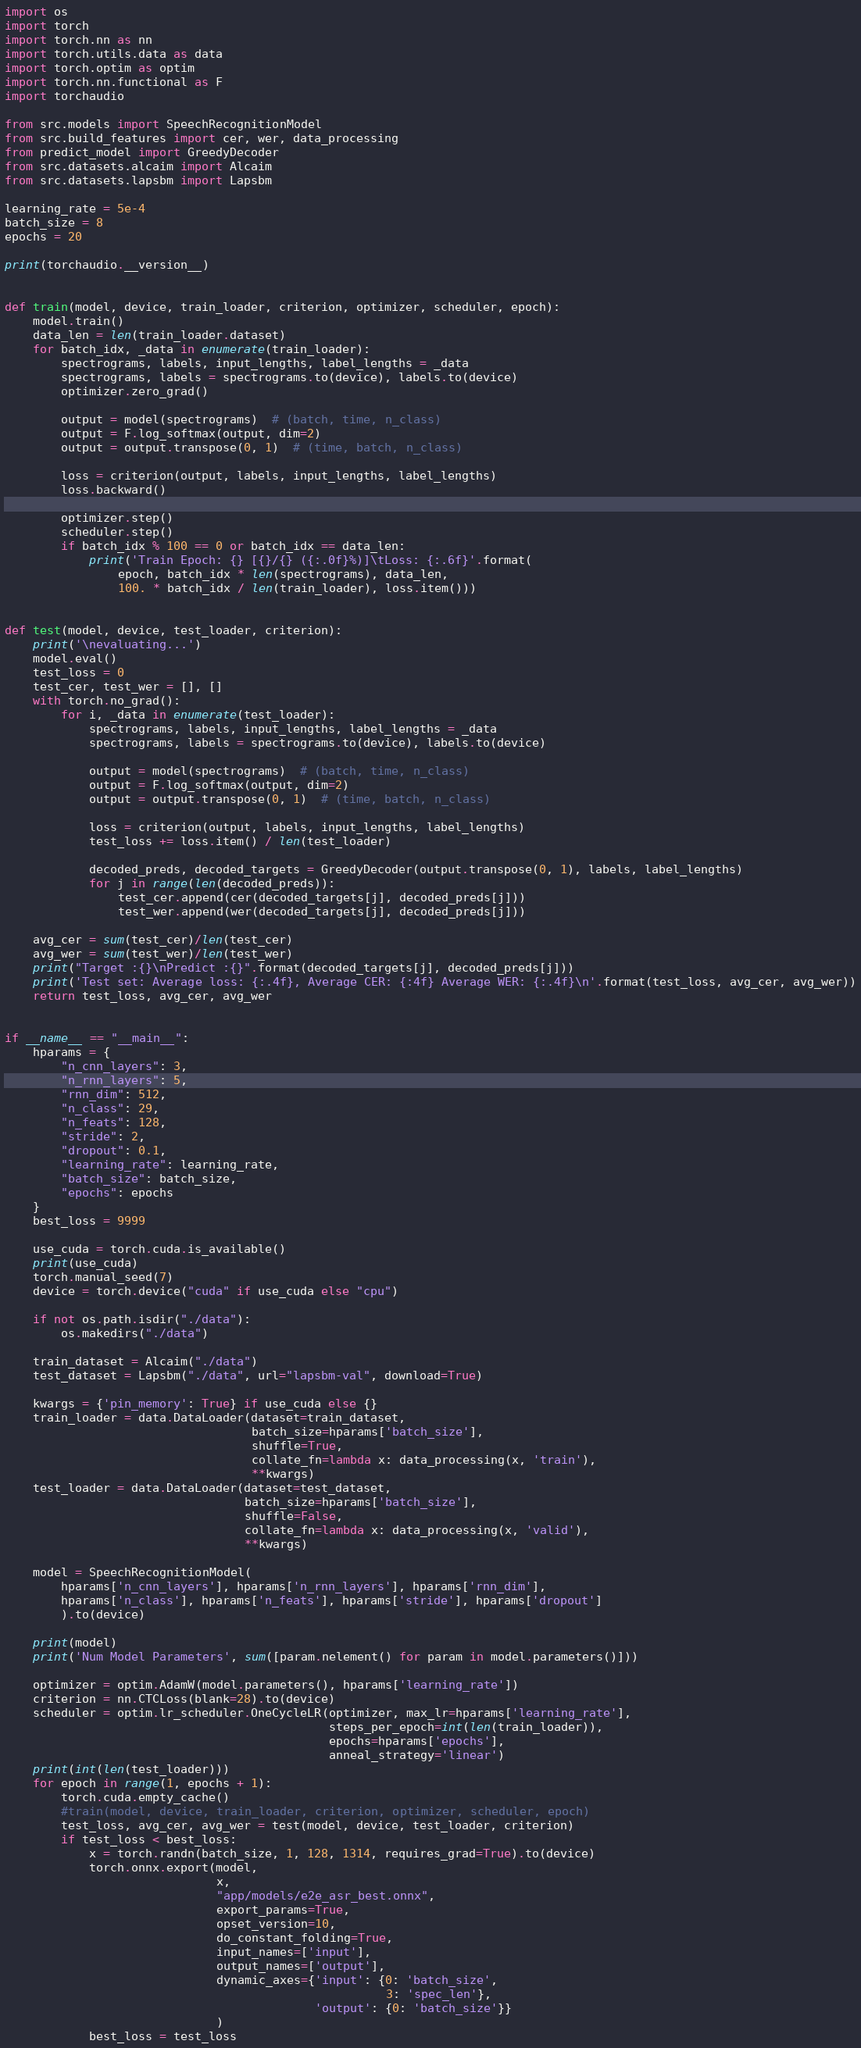Convert code to text. <code><loc_0><loc_0><loc_500><loc_500><_Python_>import os
import torch
import torch.nn as nn
import torch.utils.data as data
import torch.optim as optim
import torch.nn.functional as F
import torchaudio

from src.models import SpeechRecognitionModel
from src.build_features import cer, wer, data_processing
from predict_model import GreedyDecoder
from src.datasets.alcaim import Alcaim
from src.datasets.lapsbm import Lapsbm

learning_rate = 5e-4
batch_size = 8
epochs = 20

print(torchaudio.__version__)


def train(model, device, train_loader, criterion, optimizer, scheduler, epoch):
    model.train()
    data_len = len(train_loader.dataset)
    for batch_idx, _data in enumerate(train_loader):
        spectrograms, labels, input_lengths, label_lengths = _data 
        spectrograms, labels = spectrograms.to(device), labels.to(device)
        optimizer.zero_grad()

        output = model(spectrograms)  # (batch, time, n_class)
        output = F.log_softmax(output, dim=2)
        output = output.transpose(0, 1)  # (time, batch, n_class)

        loss = criterion(output, labels, input_lengths, label_lengths)
        loss.backward()

        optimizer.step()
        scheduler.step()
        if batch_idx % 100 == 0 or batch_idx == data_len:
            print('Train Epoch: {} [{}/{} ({:.0f}%)]\tLoss: {:.6f}'.format(
                epoch, batch_idx * len(spectrograms), data_len,
                100. * batch_idx / len(train_loader), loss.item()))


def test(model, device, test_loader, criterion):
    print('\nevaluating...')
    model.eval()
    test_loss = 0
    test_cer, test_wer = [], []
    with torch.no_grad():
        for i, _data in enumerate(test_loader):
            spectrograms, labels, input_lengths, label_lengths = _data 
            spectrograms, labels = spectrograms.to(device), labels.to(device)

            output = model(spectrograms)  # (batch, time, n_class)
            output = F.log_softmax(output, dim=2)
            output = output.transpose(0, 1)  # (time, batch, n_class)

            loss = criterion(output, labels, input_lengths, label_lengths)
            test_loss += loss.item() / len(test_loader)

            decoded_preds, decoded_targets = GreedyDecoder(output.transpose(0, 1), labels, label_lengths)
            for j in range(len(decoded_preds)):
                test_cer.append(cer(decoded_targets[j], decoded_preds[j]))
                test_wer.append(wer(decoded_targets[j], decoded_preds[j]))

    avg_cer = sum(test_cer)/len(test_cer)
    avg_wer = sum(test_wer)/len(test_wer)
    print("Target :{}\nPredict :{}".format(decoded_targets[j], decoded_preds[j]))
    print('Test set: Average loss: {:.4f}, Average CER: {:4f} Average WER: {:.4f}\n'.format(test_loss, avg_cer, avg_wer))
    return test_loss, avg_cer, avg_wer


if __name__ == "__main__":
    hparams = {
        "n_cnn_layers": 3,
        "n_rnn_layers": 5,
        "rnn_dim": 512,
        "n_class": 29,
        "n_feats": 128,
        "stride": 2,
        "dropout": 0.1,
        "learning_rate": learning_rate,
        "batch_size": batch_size,
        "epochs": epochs
    }
    best_loss = 9999

    use_cuda = torch.cuda.is_available()
    print(use_cuda)
    torch.manual_seed(7)
    device = torch.device("cuda" if use_cuda else "cpu")

    if not os.path.isdir("./data"):
        os.makedirs("./data")

    train_dataset = Alcaim("./data")
    test_dataset = Lapsbm("./data", url="lapsbm-val", download=True)

    kwargs = {'pin_memory': True} if use_cuda else {}
    train_loader = data.DataLoader(dataset=train_dataset,
                                   batch_size=hparams['batch_size'],
                                   shuffle=True,
                                   collate_fn=lambda x: data_processing(x, 'train'),
                                   **kwargs)
    test_loader = data.DataLoader(dataset=test_dataset,
                                  batch_size=hparams['batch_size'],
                                  shuffle=False,
                                  collate_fn=lambda x: data_processing(x, 'valid'),
                                  **kwargs)

    model = SpeechRecognitionModel(
        hparams['n_cnn_layers'], hparams['n_rnn_layers'], hparams['rnn_dim'],
        hparams['n_class'], hparams['n_feats'], hparams['stride'], hparams['dropout']
        ).to(device)

    print(model)
    print('Num Model Parameters', sum([param.nelement() for param in model.parameters()]))

    optimizer = optim.AdamW(model.parameters(), hparams['learning_rate'])
    criterion = nn.CTCLoss(blank=28).to(device)
    scheduler = optim.lr_scheduler.OneCycleLR(optimizer, max_lr=hparams['learning_rate'], 
                                              steps_per_epoch=int(len(train_loader)),
                                              epochs=hparams['epochs'],
                                              anneal_strategy='linear')
    print(int(len(test_loader)))
    for epoch in range(1, epochs + 1):
        torch.cuda.empty_cache()
        #train(model, device, train_loader, criterion, optimizer, scheduler, epoch)
        test_loss, avg_cer, avg_wer = test(model, device, test_loader, criterion)
        if test_loss < best_loss:
            x = torch.randn(batch_size, 1, 128, 1314, requires_grad=True).to(device)
            torch.onnx.export(model,
                              x,
                              "app/models/e2e_asr_best.onnx",
                              export_params=True,
                              opset_version=10,
                              do_constant_folding=True,
                              input_names=['input'],
                              output_names=['output'],
                              dynamic_axes={'input': {0: 'batch_size',
                                                      3: 'spec_len'},
                                            'output': {0: 'batch_size'}}
                              )
            best_loss = test_loss
</code> 